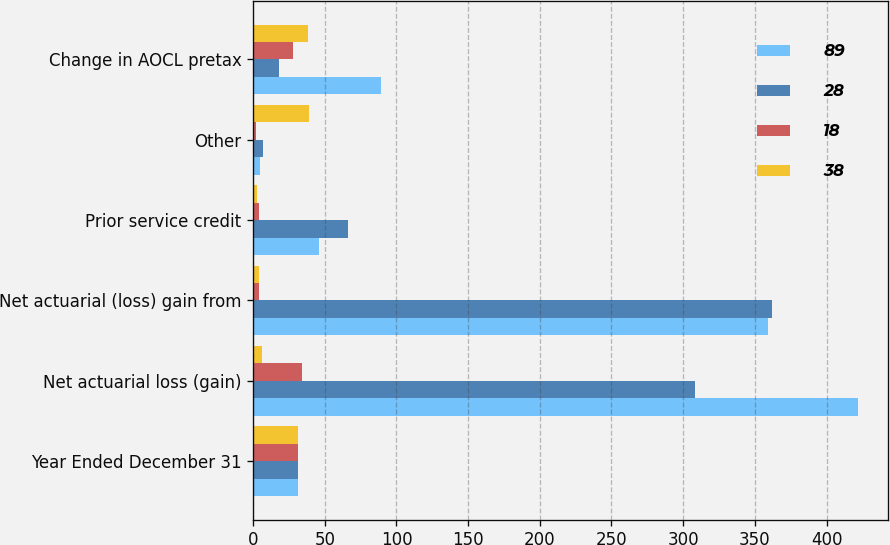Convert chart. <chart><loc_0><loc_0><loc_500><loc_500><stacked_bar_chart><ecel><fcel>Year Ended December 31<fcel>Net actuarial loss (gain)<fcel>Net actuarial (loss) gain from<fcel>Prior service credit<fcel>Other<fcel>Change in AOCL pretax<nl><fcel>89<fcel>31<fcel>422<fcel>359<fcel>46<fcel>5<fcel>89<nl><fcel>28<fcel>31<fcel>308<fcel>362<fcel>66<fcel>7<fcel>18<nl><fcel>18<fcel>31<fcel>34<fcel>4<fcel>4<fcel>2<fcel>28<nl><fcel>38<fcel>31<fcel>6<fcel>4<fcel>3<fcel>39<fcel>38<nl></chart> 